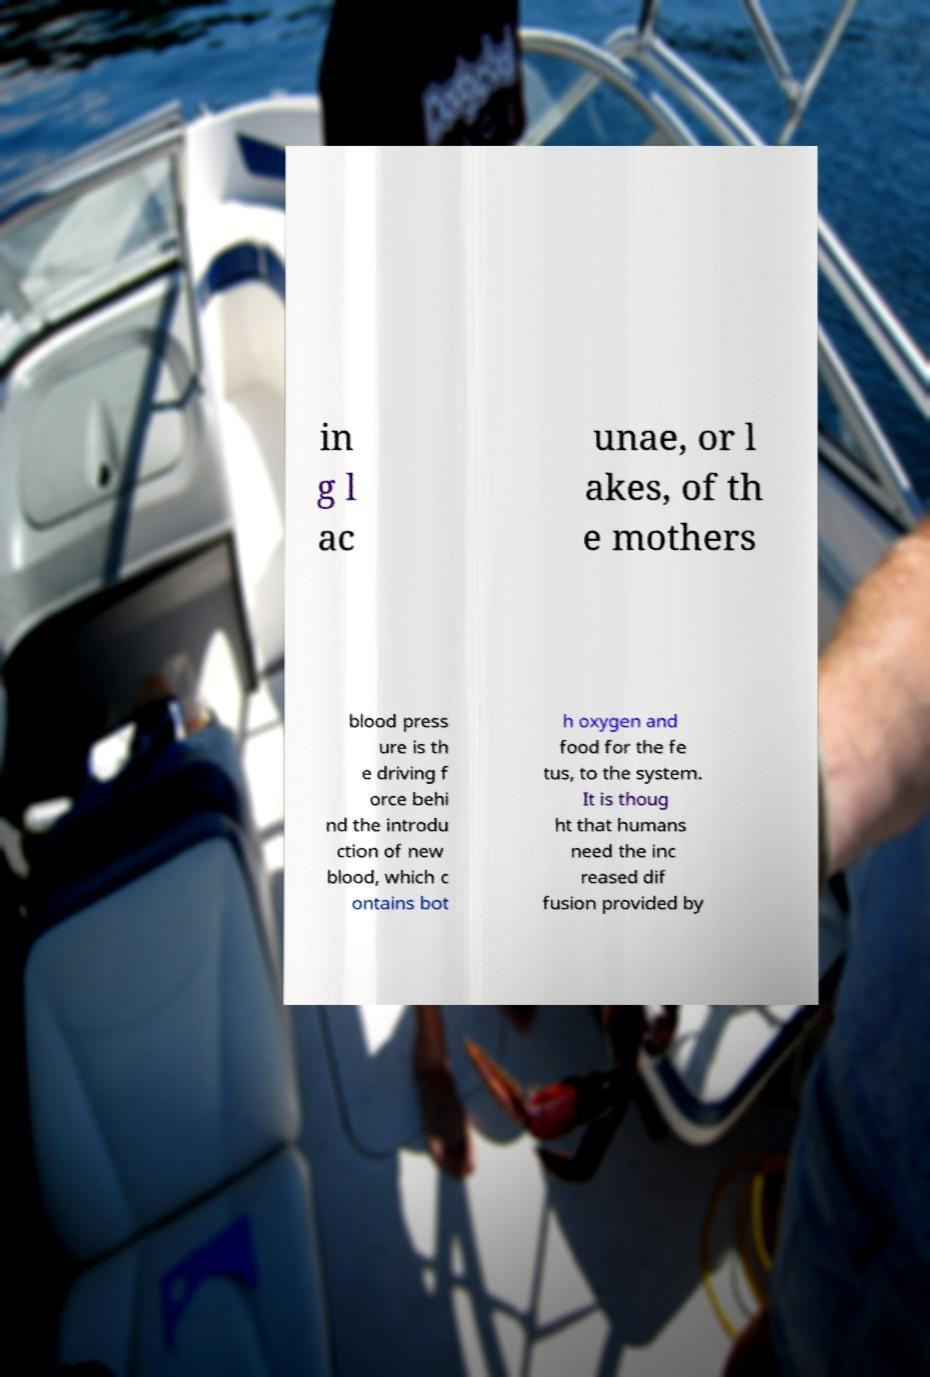There's text embedded in this image that I need extracted. Can you transcribe it verbatim? in g l ac unae, or l akes, of th e mothers blood press ure is th e driving f orce behi nd the introdu ction of new blood, which c ontains bot h oxygen and food for the fe tus, to the system. It is thoug ht that humans need the inc reased dif fusion provided by 